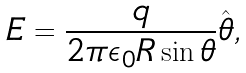Convert formula to latex. <formula><loc_0><loc_0><loc_500><loc_500>E = \frac { q } { 2 \pi \epsilon _ { 0 } R \sin \theta } \hat { \boldsymbol \theta } ,</formula> 